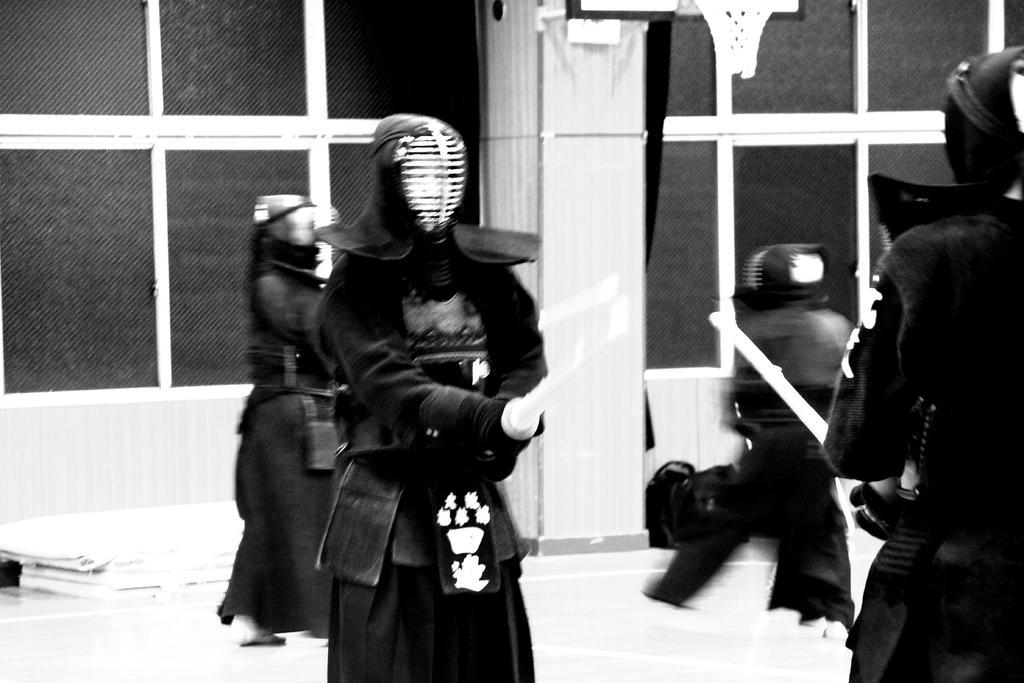In one or two sentences, can you explain what this image depicts? This looks like a black and white image. I can see few people standing. They wore armour´s. I can see two people holding the bamboo swords. I think they are doing Kendo. In the background, that looks like a building with the glass doors. 